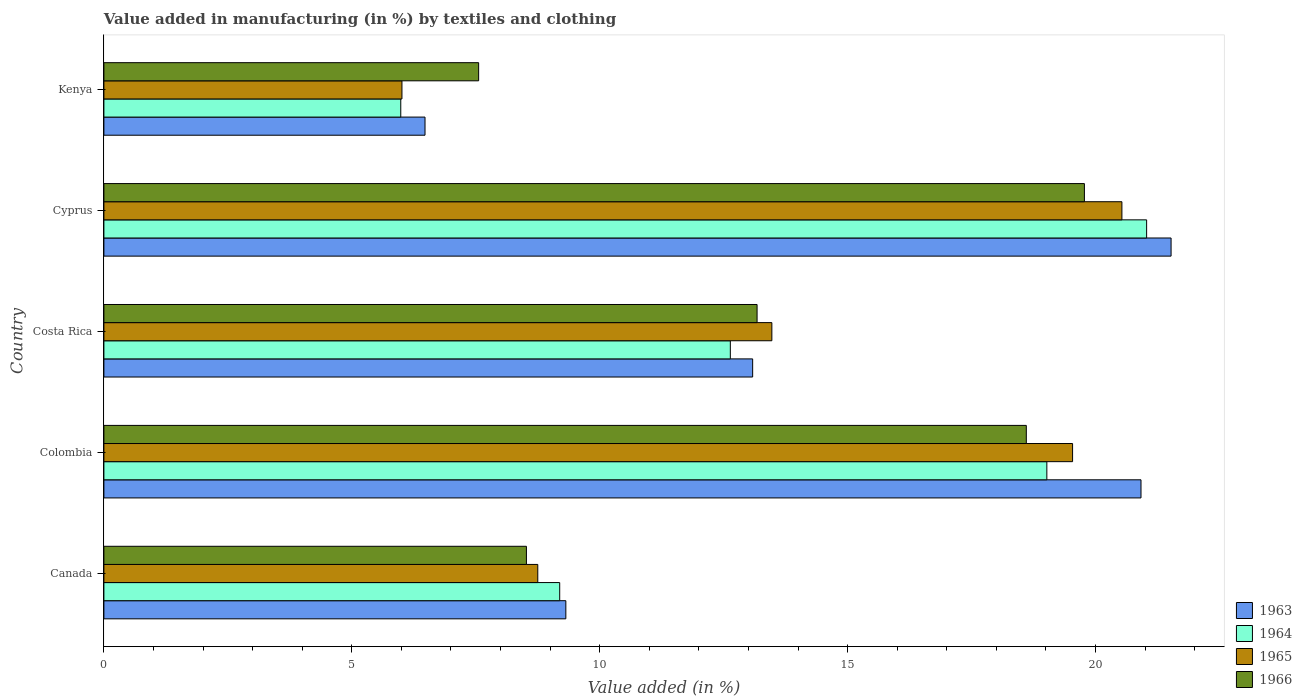Are the number of bars per tick equal to the number of legend labels?
Your response must be concise. Yes. How many bars are there on the 2nd tick from the top?
Provide a short and direct response. 4. How many bars are there on the 3rd tick from the bottom?
Ensure brevity in your answer.  4. What is the label of the 2nd group of bars from the top?
Ensure brevity in your answer.  Cyprus. In how many cases, is the number of bars for a given country not equal to the number of legend labels?
Ensure brevity in your answer.  0. What is the percentage of value added in manufacturing by textiles and clothing in 1964 in Kenya?
Your answer should be very brief. 5.99. Across all countries, what is the maximum percentage of value added in manufacturing by textiles and clothing in 1963?
Give a very brief answer. 21.52. Across all countries, what is the minimum percentage of value added in manufacturing by textiles and clothing in 1963?
Your answer should be compact. 6.48. In which country was the percentage of value added in manufacturing by textiles and clothing in 1964 maximum?
Give a very brief answer. Cyprus. In which country was the percentage of value added in manufacturing by textiles and clothing in 1966 minimum?
Ensure brevity in your answer.  Kenya. What is the total percentage of value added in manufacturing by textiles and clothing in 1965 in the graph?
Offer a terse response. 68.3. What is the difference between the percentage of value added in manufacturing by textiles and clothing in 1964 in Canada and that in Costa Rica?
Give a very brief answer. -3.44. What is the difference between the percentage of value added in manufacturing by textiles and clothing in 1966 in Colombia and the percentage of value added in manufacturing by textiles and clothing in 1964 in Canada?
Give a very brief answer. 9.41. What is the average percentage of value added in manufacturing by textiles and clothing in 1963 per country?
Give a very brief answer. 14.26. What is the difference between the percentage of value added in manufacturing by textiles and clothing in 1966 and percentage of value added in manufacturing by textiles and clothing in 1964 in Kenya?
Your response must be concise. 1.57. In how many countries, is the percentage of value added in manufacturing by textiles and clothing in 1965 greater than 19 %?
Keep it short and to the point. 2. What is the ratio of the percentage of value added in manufacturing by textiles and clothing in 1965 in Colombia to that in Kenya?
Your answer should be compact. 3.25. Is the percentage of value added in manufacturing by textiles and clothing in 1964 in Colombia less than that in Costa Rica?
Provide a short and direct response. No. What is the difference between the highest and the second highest percentage of value added in manufacturing by textiles and clothing in 1965?
Give a very brief answer. 0.99. What is the difference between the highest and the lowest percentage of value added in manufacturing by textiles and clothing in 1965?
Keep it short and to the point. 14.52. What does the 1st bar from the top in Canada represents?
Your answer should be compact. 1966. What does the 2nd bar from the bottom in Costa Rica represents?
Give a very brief answer. 1964. Is it the case that in every country, the sum of the percentage of value added in manufacturing by textiles and clothing in 1966 and percentage of value added in manufacturing by textiles and clothing in 1964 is greater than the percentage of value added in manufacturing by textiles and clothing in 1965?
Ensure brevity in your answer.  Yes. How many bars are there?
Keep it short and to the point. 20. Are all the bars in the graph horizontal?
Your answer should be very brief. Yes. How many countries are there in the graph?
Ensure brevity in your answer.  5. What is the difference between two consecutive major ticks on the X-axis?
Ensure brevity in your answer.  5. Are the values on the major ticks of X-axis written in scientific E-notation?
Provide a short and direct response. No. Does the graph contain any zero values?
Make the answer very short. No. Where does the legend appear in the graph?
Ensure brevity in your answer.  Bottom right. How many legend labels are there?
Offer a very short reply. 4. What is the title of the graph?
Ensure brevity in your answer.  Value added in manufacturing (in %) by textiles and clothing. What is the label or title of the X-axis?
Give a very brief answer. Value added (in %). What is the label or title of the Y-axis?
Make the answer very short. Country. What is the Value added (in %) in 1963 in Canada?
Make the answer very short. 9.32. What is the Value added (in %) of 1964 in Canada?
Your answer should be very brief. 9.19. What is the Value added (in %) in 1965 in Canada?
Your answer should be very brief. 8.75. What is the Value added (in %) in 1966 in Canada?
Keep it short and to the point. 8.52. What is the Value added (in %) of 1963 in Colombia?
Give a very brief answer. 20.92. What is the Value added (in %) of 1964 in Colombia?
Make the answer very short. 19.02. What is the Value added (in %) in 1965 in Colombia?
Offer a very short reply. 19.54. What is the Value added (in %) in 1966 in Colombia?
Your answer should be very brief. 18.6. What is the Value added (in %) in 1963 in Costa Rica?
Ensure brevity in your answer.  13.08. What is the Value added (in %) in 1964 in Costa Rica?
Your response must be concise. 12.63. What is the Value added (in %) in 1965 in Costa Rica?
Keep it short and to the point. 13.47. What is the Value added (in %) in 1966 in Costa Rica?
Ensure brevity in your answer.  13.17. What is the Value added (in %) in 1963 in Cyprus?
Offer a terse response. 21.52. What is the Value added (in %) in 1964 in Cyprus?
Your answer should be very brief. 21.03. What is the Value added (in %) in 1965 in Cyprus?
Your response must be concise. 20.53. What is the Value added (in %) in 1966 in Cyprus?
Your answer should be compact. 19.78. What is the Value added (in %) in 1963 in Kenya?
Your answer should be compact. 6.48. What is the Value added (in %) in 1964 in Kenya?
Offer a terse response. 5.99. What is the Value added (in %) in 1965 in Kenya?
Your answer should be compact. 6.01. What is the Value added (in %) of 1966 in Kenya?
Offer a very short reply. 7.56. Across all countries, what is the maximum Value added (in %) in 1963?
Provide a succinct answer. 21.52. Across all countries, what is the maximum Value added (in %) of 1964?
Provide a short and direct response. 21.03. Across all countries, what is the maximum Value added (in %) of 1965?
Offer a very short reply. 20.53. Across all countries, what is the maximum Value added (in %) of 1966?
Ensure brevity in your answer.  19.78. Across all countries, what is the minimum Value added (in %) in 1963?
Give a very brief answer. 6.48. Across all countries, what is the minimum Value added (in %) of 1964?
Keep it short and to the point. 5.99. Across all countries, what is the minimum Value added (in %) of 1965?
Offer a very short reply. 6.01. Across all countries, what is the minimum Value added (in %) in 1966?
Give a very brief answer. 7.56. What is the total Value added (in %) in 1963 in the graph?
Make the answer very short. 71.32. What is the total Value added (in %) of 1964 in the graph?
Your answer should be very brief. 67.86. What is the total Value added (in %) in 1965 in the graph?
Keep it short and to the point. 68.3. What is the total Value added (in %) of 1966 in the graph?
Offer a very short reply. 67.63. What is the difference between the Value added (in %) of 1963 in Canada and that in Colombia?
Provide a succinct answer. -11.6. What is the difference between the Value added (in %) of 1964 in Canada and that in Colombia?
Ensure brevity in your answer.  -9.82. What is the difference between the Value added (in %) of 1965 in Canada and that in Colombia?
Give a very brief answer. -10.79. What is the difference between the Value added (in %) of 1966 in Canada and that in Colombia?
Provide a short and direct response. -10.08. What is the difference between the Value added (in %) of 1963 in Canada and that in Costa Rica?
Provide a short and direct response. -3.77. What is the difference between the Value added (in %) in 1964 in Canada and that in Costa Rica?
Your answer should be compact. -3.44. What is the difference between the Value added (in %) of 1965 in Canada and that in Costa Rica?
Offer a very short reply. -4.72. What is the difference between the Value added (in %) of 1966 in Canada and that in Costa Rica?
Offer a terse response. -4.65. What is the difference between the Value added (in %) in 1963 in Canada and that in Cyprus?
Offer a terse response. -12.21. What is the difference between the Value added (in %) in 1964 in Canada and that in Cyprus?
Keep it short and to the point. -11.84. What is the difference between the Value added (in %) in 1965 in Canada and that in Cyprus?
Offer a very short reply. -11.78. What is the difference between the Value added (in %) in 1966 in Canada and that in Cyprus?
Your answer should be compact. -11.25. What is the difference between the Value added (in %) in 1963 in Canada and that in Kenya?
Keep it short and to the point. 2.84. What is the difference between the Value added (in %) in 1964 in Canada and that in Kenya?
Offer a very short reply. 3.21. What is the difference between the Value added (in %) in 1965 in Canada and that in Kenya?
Keep it short and to the point. 2.74. What is the difference between the Value added (in %) in 1966 in Canada and that in Kenya?
Ensure brevity in your answer.  0.96. What is the difference between the Value added (in %) in 1963 in Colombia and that in Costa Rica?
Ensure brevity in your answer.  7.83. What is the difference between the Value added (in %) in 1964 in Colombia and that in Costa Rica?
Provide a succinct answer. 6.38. What is the difference between the Value added (in %) of 1965 in Colombia and that in Costa Rica?
Keep it short and to the point. 6.06. What is the difference between the Value added (in %) of 1966 in Colombia and that in Costa Rica?
Ensure brevity in your answer.  5.43. What is the difference between the Value added (in %) in 1963 in Colombia and that in Cyprus?
Offer a terse response. -0.61. What is the difference between the Value added (in %) in 1964 in Colombia and that in Cyprus?
Offer a very short reply. -2.01. What is the difference between the Value added (in %) in 1965 in Colombia and that in Cyprus?
Your answer should be compact. -0.99. What is the difference between the Value added (in %) in 1966 in Colombia and that in Cyprus?
Offer a terse response. -1.17. What is the difference between the Value added (in %) of 1963 in Colombia and that in Kenya?
Your response must be concise. 14.44. What is the difference between the Value added (in %) in 1964 in Colombia and that in Kenya?
Keep it short and to the point. 13.03. What is the difference between the Value added (in %) in 1965 in Colombia and that in Kenya?
Provide a succinct answer. 13.53. What is the difference between the Value added (in %) of 1966 in Colombia and that in Kenya?
Your answer should be compact. 11.05. What is the difference between the Value added (in %) of 1963 in Costa Rica and that in Cyprus?
Make the answer very short. -8.44. What is the difference between the Value added (in %) in 1964 in Costa Rica and that in Cyprus?
Offer a very short reply. -8.4. What is the difference between the Value added (in %) in 1965 in Costa Rica and that in Cyprus?
Offer a very short reply. -7.06. What is the difference between the Value added (in %) of 1966 in Costa Rica and that in Cyprus?
Give a very brief answer. -6.6. What is the difference between the Value added (in %) of 1963 in Costa Rica and that in Kenya?
Give a very brief answer. 6.61. What is the difference between the Value added (in %) in 1964 in Costa Rica and that in Kenya?
Offer a terse response. 6.65. What is the difference between the Value added (in %) in 1965 in Costa Rica and that in Kenya?
Your answer should be very brief. 7.46. What is the difference between the Value added (in %) of 1966 in Costa Rica and that in Kenya?
Your response must be concise. 5.62. What is the difference between the Value added (in %) of 1963 in Cyprus and that in Kenya?
Provide a short and direct response. 15.05. What is the difference between the Value added (in %) of 1964 in Cyprus and that in Kenya?
Provide a short and direct response. 15.04. What is the difference between the Value added (in %) in 1965 in Cyprus and that in Kenya?
Your answer should be compact. 14.52. What is the difference between the Value added (in %) of 1966 in Cyprus and that in Kenya?
Offer a very short reply. 12.22. What is the difference between the Value added (in %) of 1963 in Canada and the Value added (in %) of 1964 in Colombia?
Your answer should be compact. -9.7. What is the difference between the Value added (in %) of 1963 in Canada and the Value added (in %) of 1965 in Colombia?
Offer a very short reply. -10.22. What is the difference between the Value added (in %) in 1963 in Canada and the Value added (in %) in 1966 in Colombia?
Your answer should be very brief. -9.29. What is the difference between the Value added (in %) in 1964 in Canada and the Value added (in %) in 1965 in Colombia?
Provide a succinct answer. -10.34. What is the difference between the Value added (in %) in 1964 in Canada and the Value added (in %) in 1966 in Colombia?
Your answer should be compact. -9.41. What is the difference between the Value added (in %) of 1965 in Canada and the Value added (in %) of 1966 in Colombia?
Give a very brief answer. -9.85. What is the difference between the Value added (in %) in 1963 in Canada and the Value added (in %) in 1964 in Costa Rica?
Keep it short and to the point. -3.32. What is the difference between the Value added (in %) of 1963 in Canada and the Value added (in %) of 1965 in Costa Rica?
Keep it short and to the point. -4.16. What is the difference between the Value added (in %) in 1963 in Canada and the Value added (in %) in 1966 in Costa Rica?
Provide a short and direct response. -3.86. What is the difference between the Value added (in %) of 1964 in Canada and the Value added (in %) of 1965 in Costa Rica?
Offer a terse response. -4.28. What is the difference between the Value added (in %) in 1964 in Canada and the Value added (in %) in 1966 in Costa Rica?
Give a very brief answer. -3.98. What is the difference between the Value added (in %) in 1965 in Canada and the Value added (in %) in 1966 in Costa Rica?
Keep it short and to the point. -4.42. What is the difference between the Value added (in %) in 1963 in Canada and the Value added (in %) in 1964 in Cyprus?
Provide a short and direct response. -11.71. What is the difference between the Value added (in %) in 1963 in Canada and the Value added (in %) in 1965 in Cyprus?
Your answer should be very brief. -11.21. What is the difference between the Value added (in %) of 1963 in Canada and the Value added (in %) of 1966 in Cyprus?
Provide a succinct answer. -10.46. What is the difference between the Value added (in %) of 1964 in Canada and the Value added (in %) of 1965 in Cyprus?
Your response must be concise. -11.34. What is the difference between the Value added (in %) in 1964 in Canada and the Value added (in %) in 1966 in Cyprus?
Ensure brevity in your answer.  -10.58. What is the difference between the Value added (in %) of 1965 in Canada and the Value added (in %) of 1966 in Cyprus?
Your answer should be compact. -11.02. What is the difference between the Value added (in %) of 1963 in Canada and the Value added (in %) of 1964 in Kenya?
Offer a very short reply. 3.33. What is the difference between the Value added (in %) in 1963 in Canada and the Value added (in %) in 1965 in Kenya?
Give a very brief answer. 3.31. What is the difference between the Value added (in %) in 1963 in Canada and the Value added (in %) in 1966 in Kenya?
Provide a succinct answer. 1.76. What is the difference between the Value added (in %) in 1964 in Canada and the Value added (in %) in 1965 in Kenya?
Ensure brevity in your answer.  3.18. What is the difference between the Value added (in %) of 1964 in Canada and the Value added (in %) of 1966 in Kenya?
Your response must be concise. 1.64. What is the difference between the Value added (in %) of 1965 in Canada and the Value added (in %) of 1966 in Kenya?
Ensure brevity in your answer.  1.19. What is the difference between the Value added (in %) in 1963 in Colombia and the Value added (in %) in 1964 in Costa Rica?
Provide a short and direct response. 8.28. What is the difference between the Value added (in %) in 1963 in Colombia and the Value added (in %) in 1965 in Costa Rica?
Offer a terse response. 7.44. What is the difference between the Value added (in %) of 1963 in Colombia and the Value added (in %) of 1966 in Costa Rica?
Give a very brief answer. 7.74. What is the difference between the Value added (in %) of 1964 in Colombia and the Value added (in %) of 1965 in Costa Rica?
Offer a terse response. 5.55. What is the difference between the Value added (in %) in 1964 in Colombia and the Value added (in %) in 1966 in Costa Rica?
Offer a very short reply. 5.84. What is the difference between the Value added (in %) in 1965 in Colombia and the Value added (in %) in 1966 in Costa Rica?
Offer a terse response. 6.36. What is the difference between the Value added (in %) in 1963 in Colombia and the Value added (in %) in 1964 in Cyprus?
Your answer should be compact. -0.11. What is the difference between the Value added (in %) in 1963 in Colombia and the Value added (in %) in 1965 in Cyprus?
Provide a short and direct response. 0.39. What is the difference between the Value added (in %) in 1963 in Colombia and the Value added (in %) in 1966 in Cyprus?
Your answer should be very brief. 1.14. What is the difference between the Value added (in %) in 1964 in Colombia and the Value added (in %) in 1965 in Cyprus?
Keep it short and to the point. -1.51. What is the difference between the Value added (in %) in 1964 in Colombia and the Value added (in %) in 1966 in Cyprus?
Offer a very short reply. -0.76. What is the difference between the Value added (in %) in 1965 in Colombia and the Value added (in %) in 1966 in Cyprus?
Make the answer very short. -0.24. What is the difference between the Value added (in %) of 1963 in Colombia and the Value added (in %) of 1964 in Kenya?
Offer a terse response. 14.93. What is the difference between the Value added (in %) of 1963 in Colombia and the Value added (in %) of 1965 in Kenya?
Your response must be concise. 14.91. What is the difference between the Value added (in %) in 1963 in Colombia and the Value added (in %) in 1966 in Kenya?
Keep it short and to the point. 13.36. What is the difference between the Value added (in %) of 1964 in Colombia and the Value added (in %) of 1965 in Kenya?
Offer a terse response. 13.01. What is the difference between the Value added (in %) in 1964 in Colombia and the Value added (in %) in 1966 in Kenya?
Give a very brief answer. 11.46. What is the difference between the Value added (in %) in 1965 in Colombia and the Value added (in %) in 1966 in Kenya?
Give a very brief answer. 11.98. What is the difference between the Value added (in %) in 1963 in Costa Rica and the Value added (in %) in 1964 in Cyprus?
Offer a terse response. -7.95. What is the difference between the Value added (in %) of 1963 in Costa Rica and the Value added (in %) of 1965 in Cyprus?
Ensure brevity in your answer.  -7.45. What is the difference between the Value added (in %) in 1963 in Costa Rica and the Value added (in %) in 1966 in Cyprus?
Your answer should be compact. -6.69. What is the difference between the Value added (in %) of 1964 in Costa Rica and the Value added (in %) of 1965 in Cyprus?
Your response must be concise. -7.9. What is the difference between the Value added (in %) in 1964 in Costa Rica and the Value added (in %) in 1966 in Cyprus?
Provide a succinct answer. -7.14. What is the difference between the Value added (in %) in 1965 in Costa Rica and the Value added (in %) in 1966 in Cyprus?
Your response must be concise. -6.3. What is the difference between the Value added (in %) of 1963 in Costa Rica and the Value added (in %) of 1964 in Kenya?
Your answer should be very brief. 7.1. What is the difference between the Value added (in %) in 1963 in Costa Rica and the Value added (in %) in 1965 in Kenya?
Give a very brief answer. 7.07. What is the difference between the Value added (in %) of 1963 in Costa Rica and the Value added (in %) of 1966 in Kenya?
Offer a terse response. 5.53. What is the difference between the Value added (in %) in 1964 in Costa Rica and the Value added (in %) in 1965 in Kenya?
Offer a very short reply. 6.62. What is the difference between the Value added (in %) of 1964 in Costa Rica and the Value added (in %) of 1966 in Kenya?
Your response must be concise. 5.08. What is the difference between the Value added (in %) in 1965 in Costa Rica and the Value added (in %) in 1966 in Kenya?
Make the answer very short. 5.91. What is the difference between the Value added (in %) in 1963 in Cyprus and the Value added (in %) in 1964 in Kenya?
Provide a short and direct response. 15.54. What is the difference between the Value added (in %) in 1963 in Cyprus and the Value added (in %) in 1965 in Kenya?
Provide a succinct answer. 15.51. What is the difference between the Value added (in %) in 1963 in Cyprus and the Value added (in %) in 1966 in Kenya?
Offer a very short reply. 13.97. What is the difference between the Value added (in %) of 1964 in Cyprus and the Value added (in %) of 1965 in Kenya?
Give a very brief answer. 15.02. What is the difference between the Value added (in %) of 1964 in Cyprus and the Value added (in %) of 1966 in Kenya?
Provide a short and direct response. 13.47. What is the difference between the Value added (in %) in 1965 in Cyprus and the Value added (in %) in 1966 in Kenya?
Provide a short and direct response. 12.97. What is the average Value added (in %) of 1963 per country?
Provide a succinct answer. 14.26. What is the average Value added (in %) of 1964 per country?
Offer a terse response. 13.57. What is the average Value added (in %) of 1965 per country?
Give a very brief answer. 13.66. What is the average Value added (in %) in 1966 per country?
Your answer should be very brief. 13.53. What is the difference between the Value added (in %) in 1963 and Value added (in %) in 1964 in Canada?
Your answer should be very brief. 0.12. What is the difference between the Value added (in %) of 1963 and Value added (in %) of 1965 in Canada?
Offer a very short reply. 0.57. What is the difference between the Value added (in %) in 1963 and Value added (in %) in 1966 in Canada?
Provide a short and direct response. 0.8. What is the difference between the Value added (in %) of 1964 and Value added (in %) of 1965 in Canada?
Make the answer very short. 0.44. What is the difference between the Value added (in %) of 1964 and Value added (in %) of 1966 in Canada?
Give a very brief answer. 0.67. What is the difference between the Value added (in %) in 1965 and Value added (in %) in 1966 in Canada?
Give a very brief answer. 0.23. What is the difference between the Value added (in %) of 1963 and Value added (in %) of 1964 in Colombia?
Offer a very short reply. 1.9. What is the difference between the Value added (in %) in 1963 and Value added (in %) in 1965 in Colombia?
Provide a succinct answer. 1.38. What is the difference between the Value added (in %) in 1963 and Value added (in %) in 1966 in Colombia?
Your answer should be very brief. 2.31. What is the difference between the Value added (in %) in 1964 and Value added (in %) in 1965 in Colombia?
Keep it short and to the point. -0.52. What is the difference between the Value added (in %) of 1964 and Value added (in %) of 1966 in Colombia?
Your response must be concise. 0.41. What is the difference between the Value added (in %) of 1965 and Value added (in %) of 1966 in Colombia?
Make the answer very short. 0.93. What is the difference between the Value added (in %) of 1963 and Value added (in %) of 1964 in Costa Rica?
Your answer should be compact. 0.45. What is the difference between the Value added (in %) in 1963 and Value added (in %) in 1965 in Costa Rica?
Offer a very short reply. -0.39. What is the difference between the Value added (in %) in 1963 and Value added (in %) in 1966 in Costa Rica?
Offer a very short reply. -0.09. What is the difference between the Value added (in %) in 1964 and Value added (in %) in 1965 in Costa Rica?
Your answer should be compact. -0.84. What is the difference between the Value added (in %) in 1964 and Value added (in %) in 1966 in Costa Rica?
Make the answer very short. -0.54. What is the difference between the Value added (in %) of 1965 and Value added (in %) of 1966 in Costa Rica?
Your answer should be compact. 0.3. What is the difference between the Value added (in %) of 1963 and Value added (in %) of 1964 in Cyprus?
Provide a succinct answer. 0.49. What is the difference between the Value added (in %) of 1963 and Value added (in %) of 1965 in Cyprus?
Give a very brief answer. 0.99. What is the difference between the Value added (in %) of 1963 and Value added (in %) of 1966 in Cyprus?
Give a very brief answer. 1.75. What is the difference between the Value added (in %) in 1964 and Value added (in %) in 1965 in Cyprus?
Your answer should be very brief. 0.5. What is the difference between the Value added (in %) in 1964 and Value added (in %) in 1966 in Cyprus?
Make the answer very short. 1.25. What is the difference between the Value added (in %) of 1965 and Value added (in %) of 1966 in Cyprus?
Your response must be concise. 0.76. What is the difference between the Value added (in %) of 1963 and Value added (in %) of 1964 in Kenya?
Your response must be concise. 0.49. What is the difference between the Value added (in %) in 1963 and Value added (in %) in 1965 in Kenya?
Offer a terse response. 0.47. What is the difference between the Value added (in %) in 1963 and Value added (in %) in 1966 in Kenya?
Provide a short and direct response. -1.08. What is the difference between the Value added (in %) of 1964 and Value added (in %) of 1965 in Kenya?
Offer a terse response. -0.02. What is the difference between the Value added (in %) in 1964 and Value added (in %) in 1966 in Kenya?
Offer a very short reply. -1.57. What is the difference between the Value added (in %) of 1965 and Value added (in %) of 1966 in Kenya?
Offer a terse response. -1.55. What is the ratio of the Value added (in %) in 1963 in Canada to that in Colombia?
Ensure brevity in your answer.  0.45. What is the ratio of the Value added (in %) of 1964 in Canada to that in Colombia?
Offer a very short reply. 0.48. What is the ratio of the Value added (in %) in 1965 in Canada to that in Colombia?
Your answer should be very brief. 0.45. What is the ratio of the Value added (in %) in 1966 in Canada to that in Colombia?
Your answer should be compact. 0.46. What is the ratio of the Value added (in %) in 1963 in Canada to that in Costa Rica?
Your response must be concise. 0.71. What is the ratio of the Value added (in %) in 1964 in Canada to that in Costa Rica?
Ensure brevity in your answer.  0.73. What is the ratio of the Value added (in %) in 1965 in Canada to that in Costa Rica?
Offer a very short reply. 0.65. What is the ratio of the Value added (in %) in 1966 in Canada to that in Costa Rica?
Your answer should be compact. 0.65. What is the ratio of the Value added (in %) of 1963 in Canada to that in Cyprus?
Provide a short and direct response. 0.43. What is the ratio of the Value added (in %) of 1964 in Canada to that in Cyprus?
Keep it short and to the point. 0.44. What is the ratio of the Value added (in %) of 1965 in Canada to that in Cyprus?
Your response must be concise. 0.43. What is the ratio of the Value added (in %) of 1966 in Canada to that in Cyprus?
Make the answer very short. 0.43. What is the ratio of the Value added (in %) in 1963 in Canada to that in Kenya?
Offer a terse response. 1.44. What is the ratio of the Value added (in %) in 1964 in Canada to that in Kenya?
Make the answer very short. 1.54. What is the ratio of the Value added (in %) of 1965 in Canada to that in Kenya?
Keep it short and to the point. 1.46. What is the ratio of the Value added (in %) of 1966 in Canada to that in Kenya?
Offer a very short reply. 1.13. What is the ratio of the Value added (in %) of 1963 in Colombia to that in Costa Rica?
Give a very brief answer. 1.6. What is the ratio of the Value added (in %) of 1964 in Colombia to that in Costa Rica?
Offer a terse response. 1.51. What is the ratio of the Value added (in %) of 1965 in Colombia to that in Costa Rica?
Provide a succinct answer. 1.45. What is the ratio of the Value added (in %) of 1966 in Colombia to that in Costa Rica?
Ensure brevity in your answer.  1.41. What is the ratio of the Value added (in %) of 1963 in Colombia to that in Cyprus?
Your answer should be very brief. 0.97. What is the ratio of the Value added (in %) in 1964 in Colombia to that in Cyprus?
Your response must be concise. 0.9. What is the ratio of the Value added (in %) of 1965 in Colombia to that in Cyprus?
Give a very brief answer. 0.95. What is the ratio of the Value added (in %) in 1966 in Colombia to that in Cyprus?
Ensure brevity in your answer.  0.94. What is the ratio of the Value added (in %) of 1963 in Colombia to that in Kenya?
Give a very brief answer. 3.23. What is the ratio of the Value added (in %) in 1964 in Colombia to that in Kenya?
Provide a succinct answer. 3.18. What is the ratio of the Value added (in %) in 1965 in Colombia to that in Kenya?
Offer a very short reply. 3.25. What is the ratio of the Value added (in %) of 1966 in Colombia to that in Kenya?
Provide a short and direct response. 2.46. What is the ratio of the Value added (in %) of 1963 in Costa Rica to that in Cyprus?
Ensure brevity in your answer.  0.61. What is the ratio of the Value added (in %) in 1964 in Costa Rica to that in Cyprus?
Your answer should be compact. 0.6. What is the ratio of the Value added (in %) in 1965 in Costa Rica to that in Cyprus?
Keep it short and to the point. 0.66. What is the ratio of the Value added (in %) of 1966 in Costa Rica to that in Cyprus?
Offer a terse response. 0.67. What is the ratio of the Value added (in %) of 1963 in Costa Rica to that in Kenya?
Your response must be concise. 2.02. What is the ratio of the Value added (in %) of 1964 in Costa Rica to that in Kenya?
Make the answer very short. 2.11. What is the ratio of the Value added (in %) in 1965 in Costa Rica to that in Kenya?
Offer a terse response. 2.24. What is the ratio of the Value added (in %) of 1966 in Costa Rica to that in Kenya?
Keep it short and to the point. 1.74. What is the ratio of the Value added (in %) in 1963 in Cyprus to that in Kenya?
Your response must be concise. 3.32. What is the ratio of the Value added (in %) of 1964 in Cyprus to that in Kenya?
Give a very brief answer. 3.51. What is the ratio of the Value added (in %) of 1965 in Cyprus to that in Kenya?
Offer a terse response. 3.42. What is the ratio of the Value added (in %) of 1966 in Cyprus to that in Kenya?
Your response must be concise. 2.62. What is the difference between the highest and the second highest Value added (in %) in 1963?
Your answer should be very brief. 0.61. What is the difference between the highest and the second highest Value added (in %) of 1964?
Your answer should be very brief. 2.01. What is the difference between the highest and the second highest Value added (in %) of 1966?
Keep it short and to the point. 1.17. What is the difference between the highest and the lowest Value added (in %) in 1963?
Your response must be concise. 15.05. What is the difference between the highest and the lowest Value added (in %) of 1964?
Give a very brief answer. 15.04. What is the difference between the highest and the lowest Value added (in %) of 1965?
Offer a very short reply. 14.52. What is the difference between the highest and the lowest Value added (in %) of 1966?
Provide a succinct answer. 12.22. 